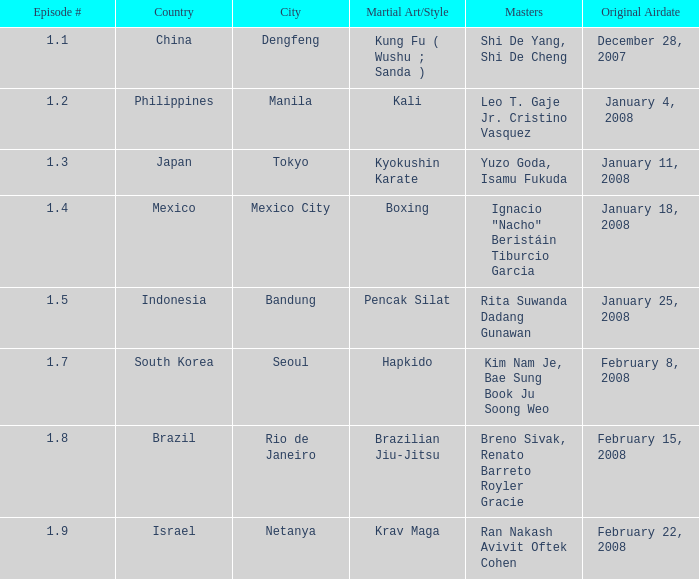Which masters engaged in hapkido style combat? Kim Nam Je, Bae Sung Book Ju Soong Weo. 